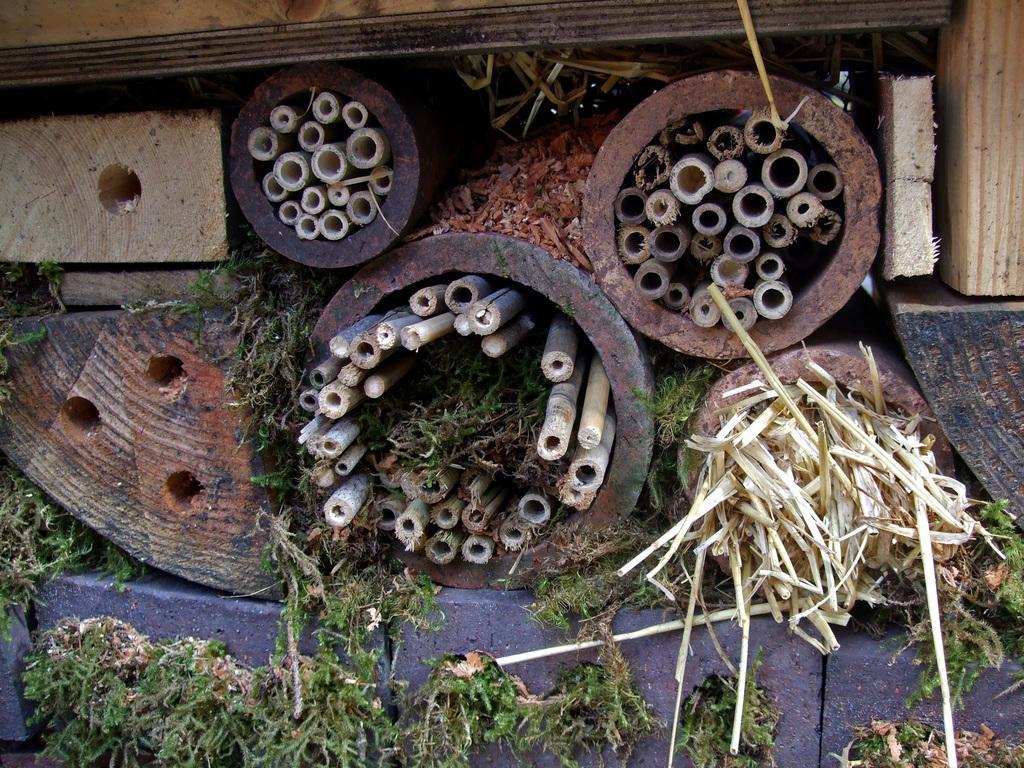Could you give a brief overview of what you see in this image? In this image I can see few wooden sticks and grass in green color. 